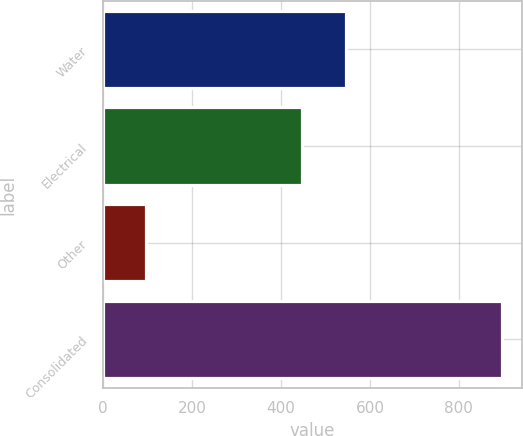Convert chart to OTSL. <chart><loc_0><loc_0><loc_500><loc_500><bar_chart><fcel>Water<fcel>Electrical<fcel>Other<fcel>Consolidated<nl><fcel>546<fcel>447<fcel>95.8<fcel>897.2<nl></chart> 